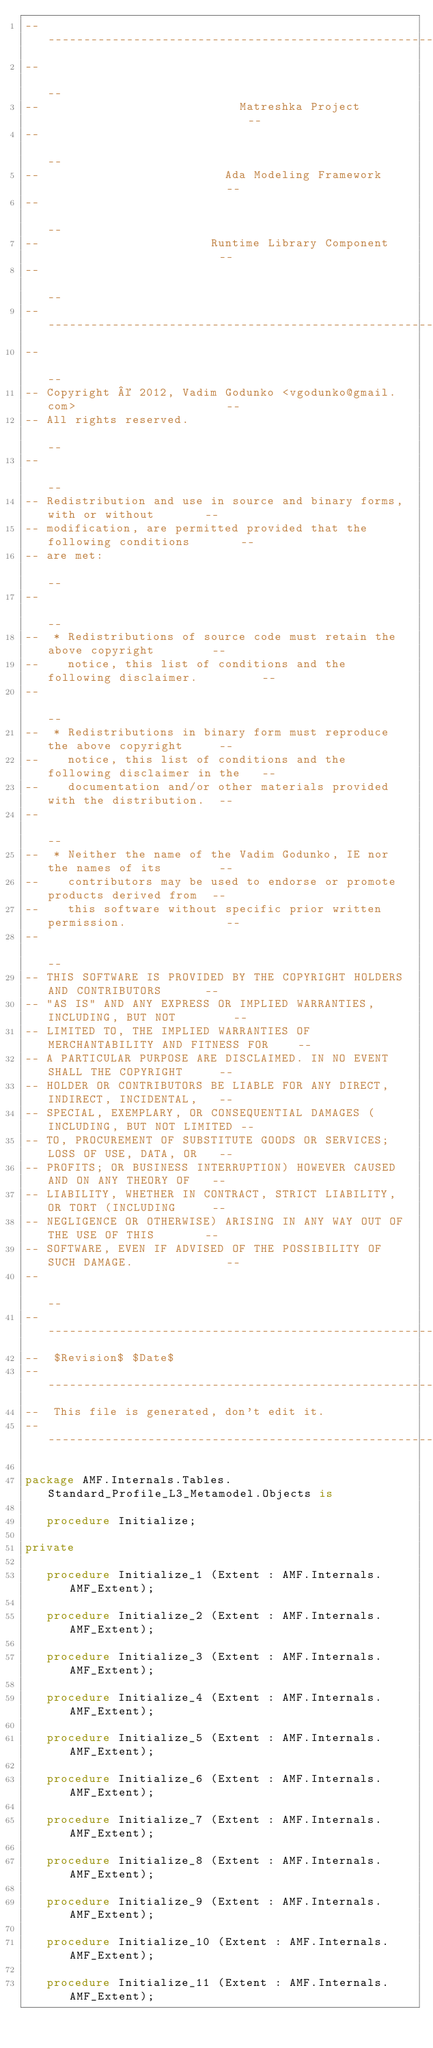<code> <loc_0><loc_0><loc_500><loc_500><_Ada_>------------------------------------------------------------------------------
--                                                                          --
--                            Matreshka Project                             --
--                                                                          --
--                          Ada Modeling Framework                          --
--                                                                          --
--                        Runtime Library Component                         --
--                                                                          --
------------------------------------------------------------------------------
--                                                                          --
-- Copyright © 2012, Vadim Godunko <vgodunko@gmail.com>                     --
-- All rights reserved.                                                     --
--                                                                          --
-- Redistribution and use in source and binary forms, with or without       --
-- modification, are permitted provided that the following conditions       --
-- are met:                                                                 --
--                                                                          --
--  * Redistributions of source code must retain the above copyright        --
--    notice, this list of conditions and the following disclaimer.         --
--                                                                          --
--  * Redistributions in binary form must reproduce the above copyright     --
--    notice, this list of conditions and the following disclaimer in the   --
--    documentation and/or other materials provided with the distribution.  --
--                                                                          --
--  * Neither the name of the Vadim Godunko, IE nor the names of its        --
--    contributors may be used to endorse or promote products derived from  --
--    this software without specific prior written permission.              --
--                                                                          --
-- THIS SOFTWARE IS PROVIDED BY THE COPYRIGHT HOLDERS AND CONTRIBUTORS      --
-- "AS IS" AND ANY EXPRESS OR IMPLIED WARRANTIES, INCLUDING, BUT NOT        --
-- LIMITED TO, THE IMPLIED WARRANTIES OF MERCHANTABILITY AND FITNESS FOR    --
-- A PARTICULAR PURPOSE ARE DISCLAIMED. IN NO EVENT SHALL THE COPYRIGHT     --
-- HOLDER OR CONTRIBUTORS BE LIABLE FOR ANY DIRECT, INDIRECT, INCIDENTAL,   --
-- SPECIAL, EXEMPLARY, OR CONSEQUENTIAL DAMAGES (INCLUDING, BUT NOT LIMITED --
-- TO, PROCUREMENT OF SUBSTITUTE GOODS OR SERVICES; LOSS OF USE, DATA, OR   --
-- PROFITS; OR BUSINESS INTERRUPTION) HOWEVER CAUSED AND ON ANY THEORY OF   --
-- LIABILITY, WHETHER IN CONTRACT, STRICT LIABILITY, OR TORT (INCLUDING     --
-- NEGLIGENCE OR OTHERWISE) ARISING IN ANY WAY OUT OF THE USE OF THIS       --
-- SOFTWARE, EVEN IF ADVISED OF THE POSSIBILITY OF SUCH DAMAGE.             --
--                                                                          --
------------------------------------------------------------------------------
--  $Revision$ $Date$
------------------------------------------------------------------------------
--  This file is generated, don't edit it.
------------------------------------------------------------------------------

package AMF.Internals.Tables.Standard_Profile_L3_Metamodel.Objects is

   procedure Initialize;

private

   procedure Initialize_1 (Extent : AMF.Internals.AMF_Extent);

   procedure Initialize_2 (Extent : AMF.Internals.AMF_Extent);

   procedure Initialize_3 (Extent : AMF.Internals.AMF_Extent);

   procedure Initialize_4 (Extent : AMF.Internals.AMF_Extent);

   procedure Initialize_5 (Extent : AMF.Internals.AMF_Extent);

   procedure Initialize_6 (Extent : AMF.Internals.AMF_Extent);

   procedure Initialize_7 (Extent : AMF.Internals.AMF_Extent);

   procedure Initialize_8 (Extent : AMF.Internals.AMF_Extent);

   procedure Initialize_9 (Extent : AMF.Internals.AMF_Extent);

   procedure Initialize_10 (Extent : AMF.Internals.AMF_Extent);

   procedure Initialize_11 (Extent : AMF.Internals.AMF_Extent);
</code> 